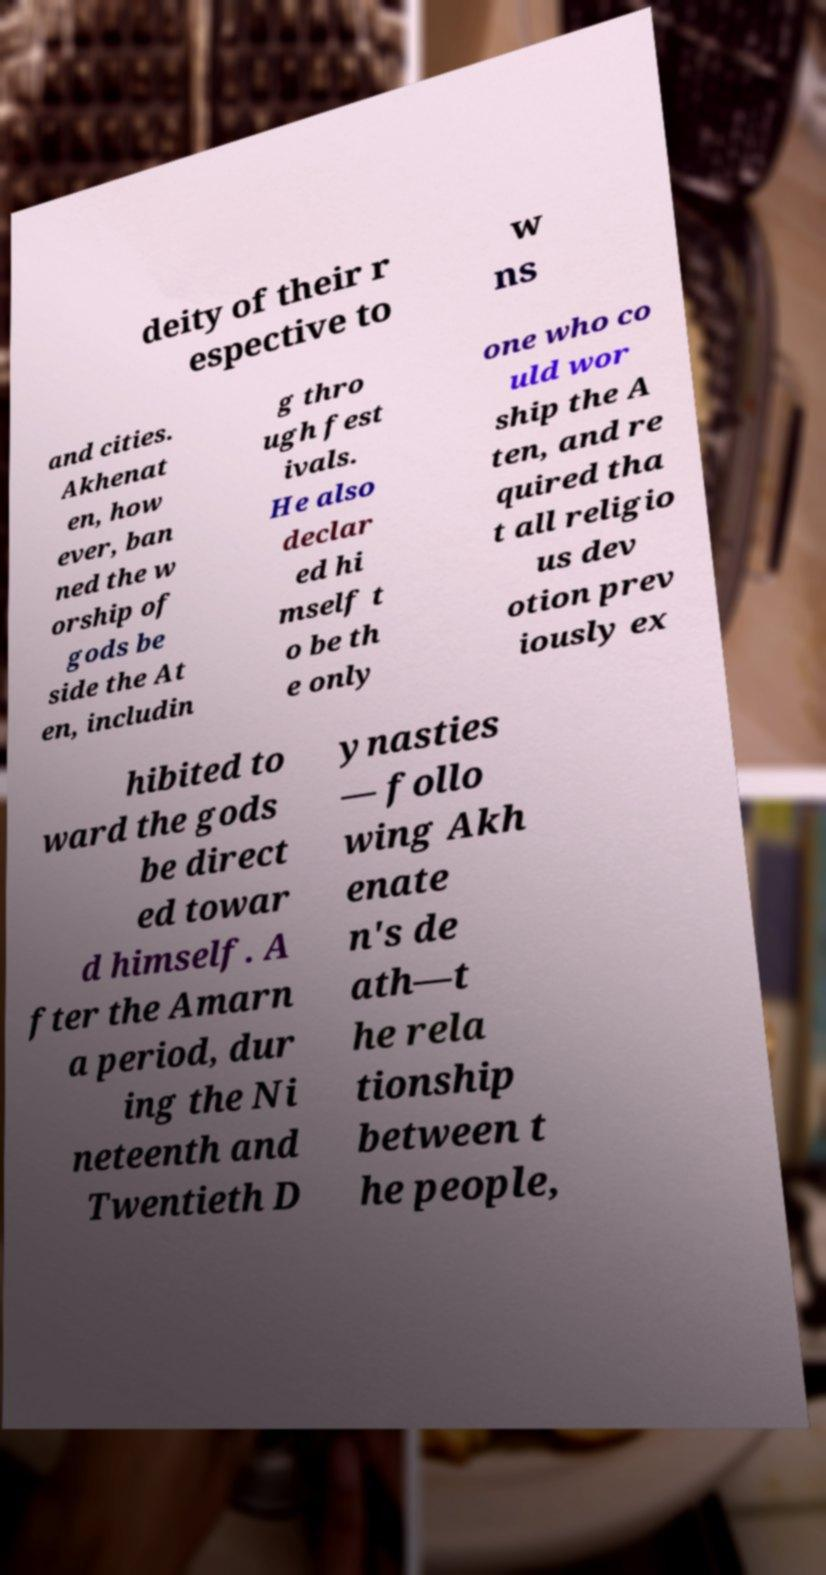Please read and relay the text visible in this image. What does it say? deity of their r espective to w ns and cities. Akhenat en, how ever, ban ned the w orship of gods be side the At en, includin g thro ugh fest ivals. He also declar ed hi mself t o be th e only one who co uld wor ship the A ten, and re quired tha t all religio us dev otion prev iously ex hibited to ward the gods be direct ed towar d himself. A fter the Amarn a period, dur ing the Ni neteenth and Twentieth D ynasties — follo wing Akh enate n's de ath—t he rela tionship between t he people, 